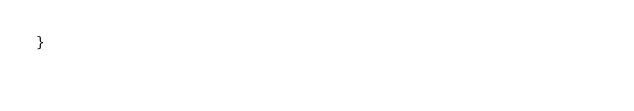Convert code to text. <code><loc_0><loc_0><loc_500><loc_500><_Java_>}
</code> 